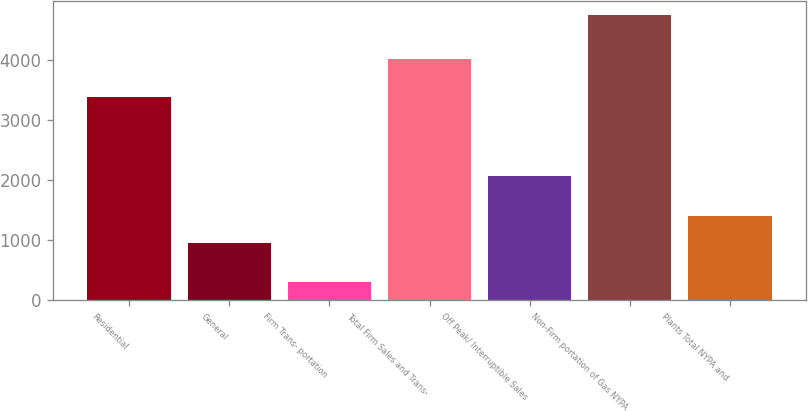Convert chart. <chart><loc_0><loc_0><loc_500><loc_500><bar_chart><fcel>Residential<fcel>General<fcel>Firm Trans- portation<fcel>Total Firm Sales and Trans-<fcel>Off Peak/ Interruptible Sales<fcel>Non-Firm portation of Gas NYPA<fcel>Plants Total NYPA and<nl><fcel>3375<fcel>953<fcel>309<fcel>4019<fcel>2060<fcel>4737<fcel>1395.8<nl></chart> 